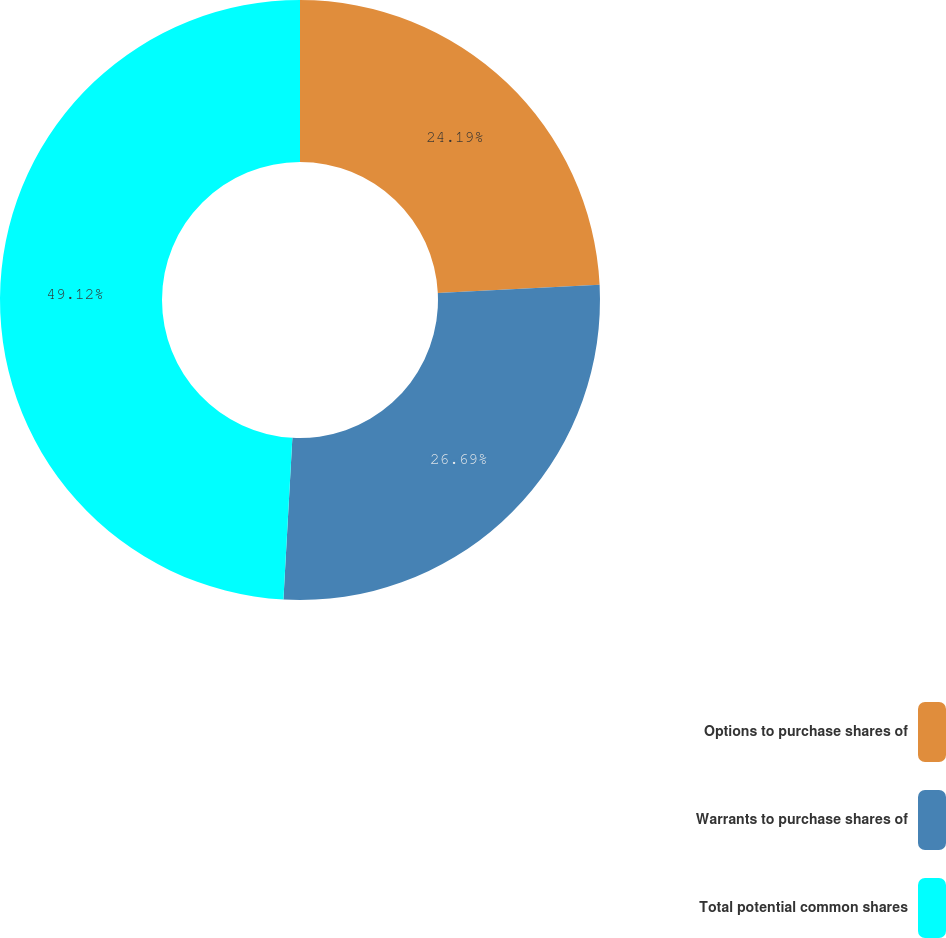Convert chart. <chart><loc_0><loc_0><loc_500><loc_500><pie_chart><fcel>Options to purchase shares of<fcel>Warrants to purchase shares of<fcel>Total potential common shares<nl><fcel>24.19%<fcel>26.69%<fcel>49.12%<nl></chart> 